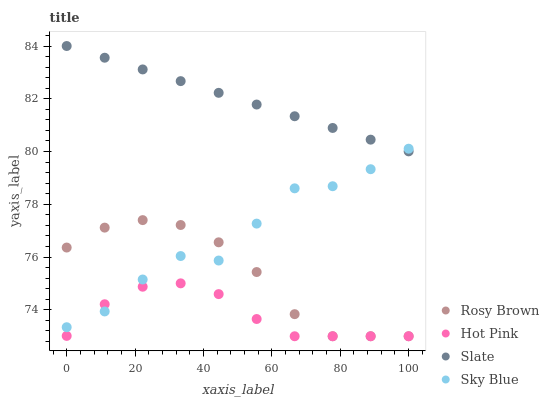Does Hot Pink have the minimum area under the curve?
Answer yes or no. Yes. Does Slate have the maximum area under the curve?
Answer yes or no. Yes. Does Rosy Brown have the minimum area under the curve?
Answer yes or no. No. Does Rosy Brown have the maximum area under the curve?
Answer yes or no. No. Is Slate the smoothest?
Answer yes or no. Yes. Is Sky Blue the roughest?
Answer yes or no. Yes. Is Rosy Brown the smoothest?
Answer yes or no. No. Is Rosy Brown the roughest?
Answer yes or no. No. Does Rosy Brown have the lowest value?
Answer yes or no. Yes. Does Slate have the lowest value?
Answer yes or no. No. Does Slate have the highest value?
Answer yes or no. Yes. Does Rosy Brown have the highest value?
Answer yes or no. No. Is Hot Pink less than Slate?
Answer yes or no. Yes. Is Slate greater than Rosy Brown?
Answer yes or no. Yes. Does Rosy Brown intersect Hot Pink?
Answer yes or no. Yes. Is Rosy Brown less than Hot Pink?
Answer yes or no. No. Is Rosy Brown greater than Hot Pink?
Answer yes or no. No. Does Hot Pink intersect Slate?
Answer yes or no. No. 